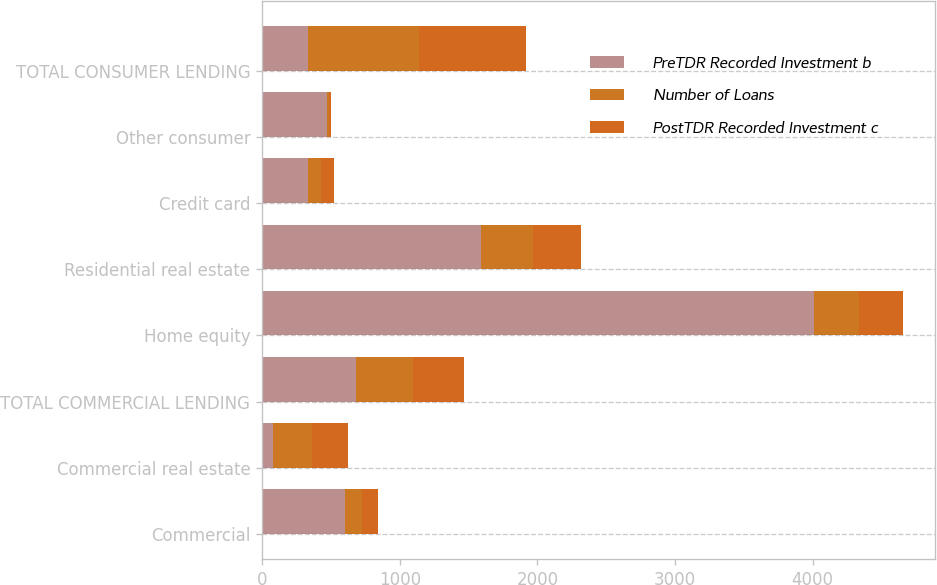Convert chart to OTSL. <chart><loc_0><loc_0><loc_500><loc_500><stacked_bar_chart><ecel><fcel>Commercial<fcel>Commercial real estate<fcel>TOTAL COMMERCIAL LENDING<fcel>Home equity<fcel>Residential real estate<fcel>Credit card<fcel>Other consumer<fcel>TOTAL CONSUMER LENDING<nl><fcel>PreTDR Recorded Investment b<fcel>599<fcel>78<fcel>679<fcel>4013<fcel>1590<fcel>336<fcel>472<fcel>336<nl><fcel>Number of Loans<fcel>129<fcel>286<fcel>416<fcel>321<fcel>376<fcel>92<fcel>13<fcel>802<nl><fcel>PostTDR Recorded Investment c<fcel>112<fcel>260<fcel>372<fcel>320<fcel>351<fcel>92<fcel>13<fcel>776<nl></chart> 